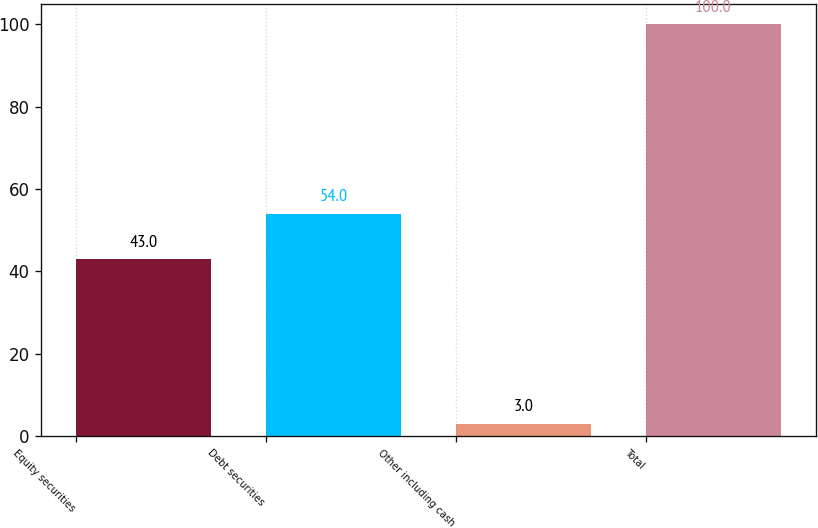Convert chart to OTSL. <chart><loc_0><loc_0><loc_500><loc_500><bar_chart><fcel>Equity securities<fcel>Debt securities<fcel>Other including cash<fcel>Total<nl><fcel>43<fcel>54<fcel>3<fcel>100<nl></chart> 